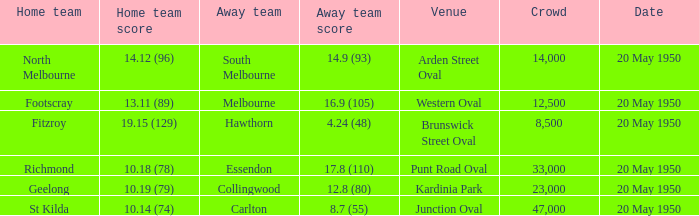What was the score for the away team that played against Richmond and has a crowd over 12,500? 17.8 (110). 